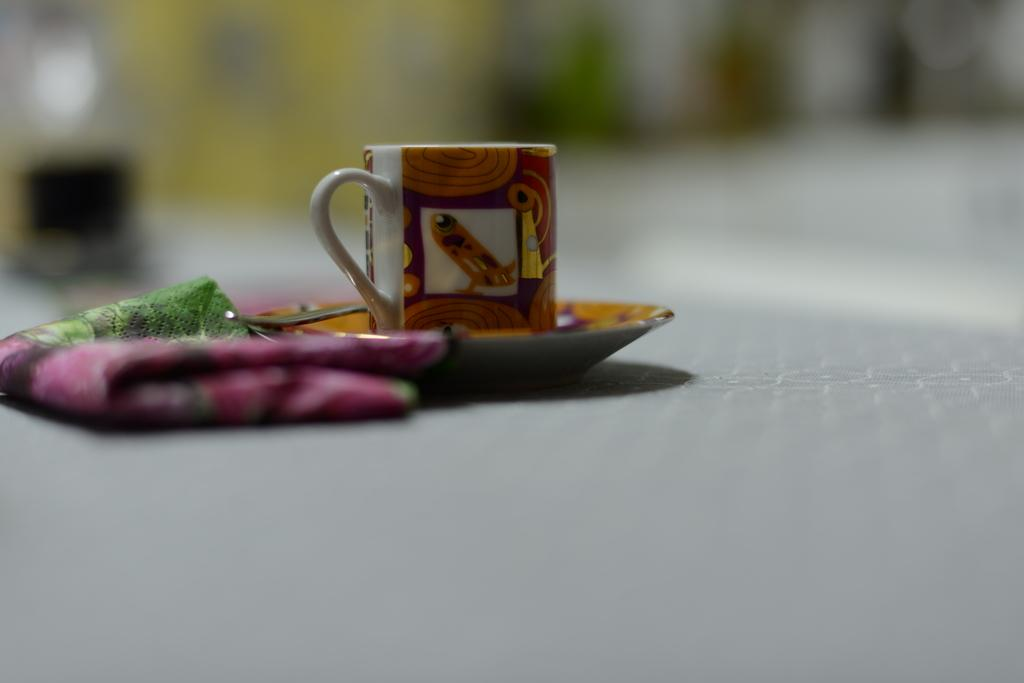What can be observed about the background of the image? The background of the picture is blurry. What objects are present in the image? There is a cup and a saucer in the image. What else can be seen in the image besides the cup and saucer? There is a cloth in the image. How many pizzas are being served by the company in the image? There are no pizzas or any reference to a company in the image. What type of growth can be observed in the image? There is no indication of growth in the image; it features a cup, saucer, and cloth. 